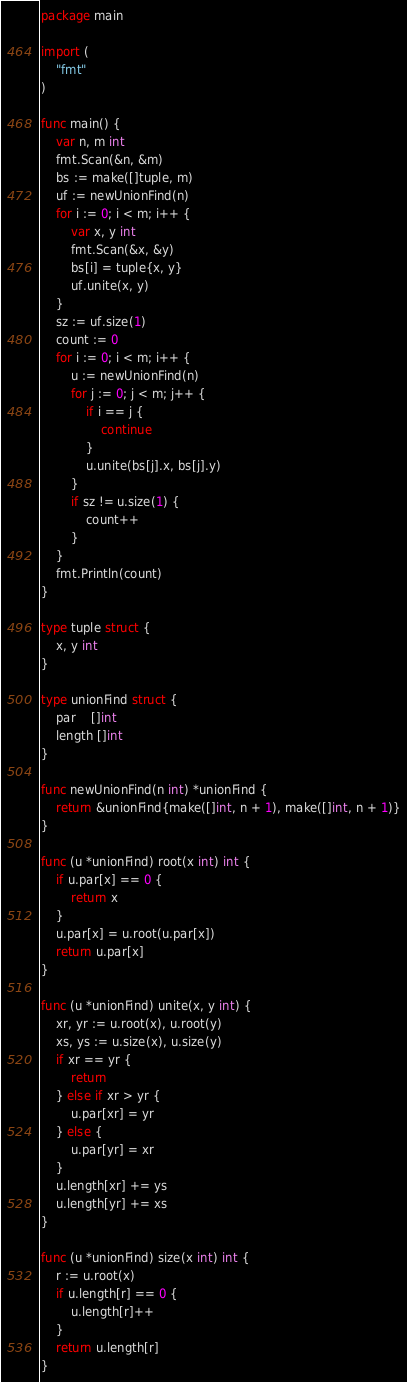Convert code to text. <code><loc_0><loc_0><loc_500><loc_500><_Go_>package main

import (
	"fmt"
)

func main() {
	var n, m int
	fmt.Scan(&n, &m)
	bs := make([]tuple, m)
	uf := newUnionFind(n)
	for i := 0; i < m; i++ {
		var x, y int
		fmt.Scan(&x, &y)
		bs[i] = tuple{x, y}
		uf.unite(x, y)
	}
	sz := uf.size(1)
	count := 0
	for i := 0; i < m; i++ {
		u := newUnionFind(n)
		for j := 0; j < m; j++ {
			if i == j {
				continue
			}
			u.unite(bs[j].x, bs[j].y)
		}
		if sz != u.size(1) {
			count++
		}
	}
	fmt.Println(count)
}

type tuple struct {
	x, y int
}

type unionFind struct {
	par    []int
	length []int
}

func newUnionFind(n int) *unionFind {
	return &unionFind{make([]int, n + 1), make([]int, n + 1)}
}

func (u *unionFind) root(x int) int {
	if u.par[x] == 0 {
		return x
	}
	u.par[x] = u.root(u.par[x])
	return u.par[x]
}

func (u *unionFind) unite(x, y int) {
	xr, yr := u.root(x), u.root(y)
	xs, ys := u.size(x), u.size(y)
	if xr == yr {
		return
	} else if xr > yr {
		u.par[xr] = yr
	} else {
		u.par[yr] = xr
	}
	u.length[xr] += ys
	u.length[yr] += xs
}

func (u *unionFind) size(x int) int {
	r := u.root(x)
	if u.length[r] == 0 {
		u.length[r]++
	}
	return u.length[r]
}</code> 